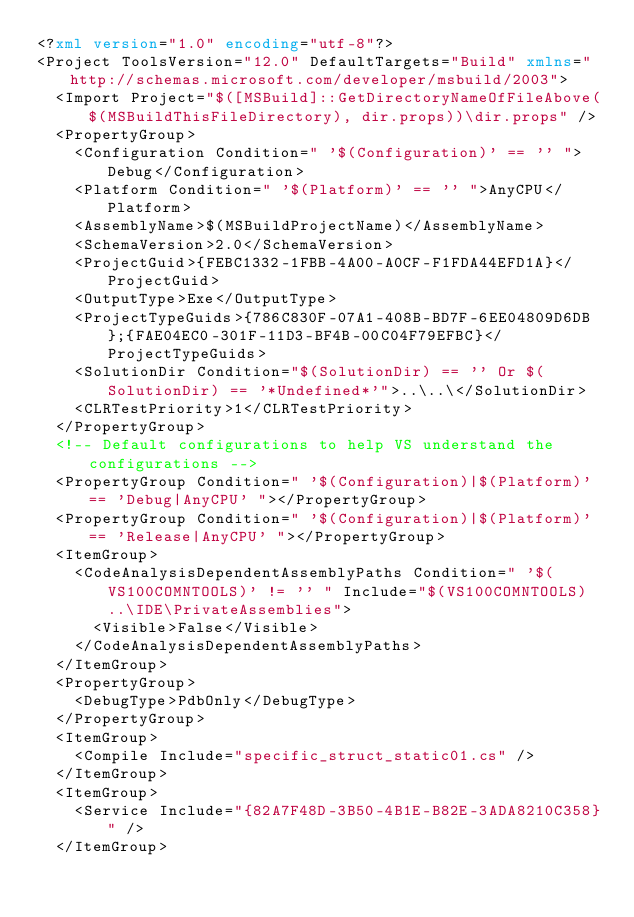<code> <loc_0><loc_0><loc_500><loc_500><_XML_><?xml version="1.0" encoding="utf-8"?>
<Project ToolsVersion="12.0" DefaultTargets="Build" xmlns="http://schemas.microsoft.com/developer/msbuild/2003">
  <Import Project="$([MSBuild]::GetDirectoryNameOfFileAbove($(MSBuildThisFileDirectory), dir.props))\dir.props" />
  <PropertyGroup>
    <Configuration Condition=" '$(Configuration)' == '' ">Debug</Configuration>
    <Platform Condition=" '$(Platform)' == '' ">AnyCPU</Platform>
    <AssemblyName>$(MSBuildProjectName)</AssemblyName>
    <SchemaVersion>2.0</SchemaVersion>
    <ProjectGuid>{FEBC1332-1FBB-4A00-A0CF-F1FDA44EFD1A}</ProjectGuid>
    <OutputType>Exe</OutputType>
    <ProjectTypeGuids>{786C830F-07A1-408B-BD7F-6EE04809D6DB};{FAE04EC0-301F-11D3-BF4B-00C04F79EFBC}</ProjectTypeGuids>
    <SolutionDir Condition="$(SolutionDir) == '' Or $(SolutionDir) == '*Undefined*'">..\..\</SolutionDir>
    <CLRTestPriority>1</CLRTestPriority>
  </PropertyGroup>
  <!-- Default configurations to help VS understand the configurations -->
  <PropertyGroup Condition=" '$(Configuration)|$(Platform)' == 'Debug|AnyCPU' "></PropertyGroup>
  <PropertyGroup Condition=" '$(Configuration)|$(Platform)' == 'Release|AnyCPU' "></PropertyGroup>
  <ItemGroup>
    <CodeAnalysisDependentAssemblyPaths Condition=" '$(VS100COMNTOOLS)' != '' " Include="$(VS100COMNTOOLS)..\IDE\PrivateAssemblies">
      <Visible>False</Visible>
    </CodeAnalysisDependentAssemblyPaths>
  </ItemGroup>
  <PropertyGroup>
    <DebugType>PdbOnly</DebugType>
  </PropertyGroup>
  <ItemGroup>
    <Compile Include="specific_struct_static01.cs" />
  </ItemGroup>
  <ItemGroup>
    <Service Include="{82A7F48D-3B50-4B1E-B82E-3ADA8210C358}" />
  </ItemGroup></code> 